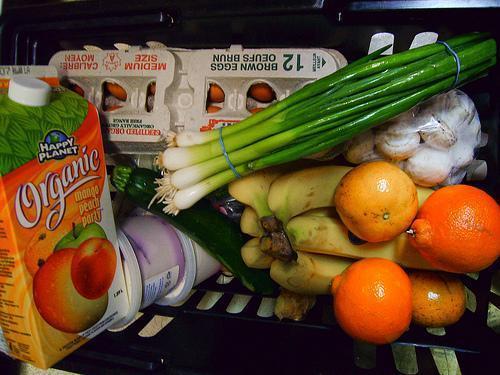How many items are there?
Give a very brief answer. 11. 